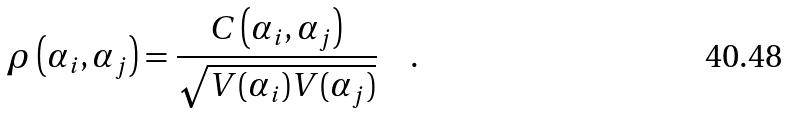<formula> <loc_0><loc_0><loc_500><loc_500>\rho \left ( \alpha _ { i } , \alpha _ { j } \right ) = \frac { C \left ( \alpha _ { i } , \alpha _ { j } \right ) } { \sqrt { V ( \alpha _ { i } ) V ( \alpha _ { j } ) } } \quad .</formula> 